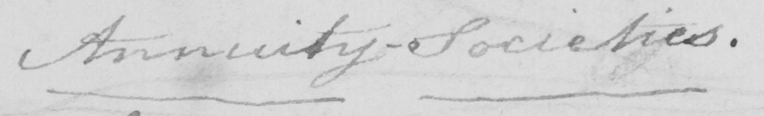What text is written in this handwritten line? Annuity-Societies . 